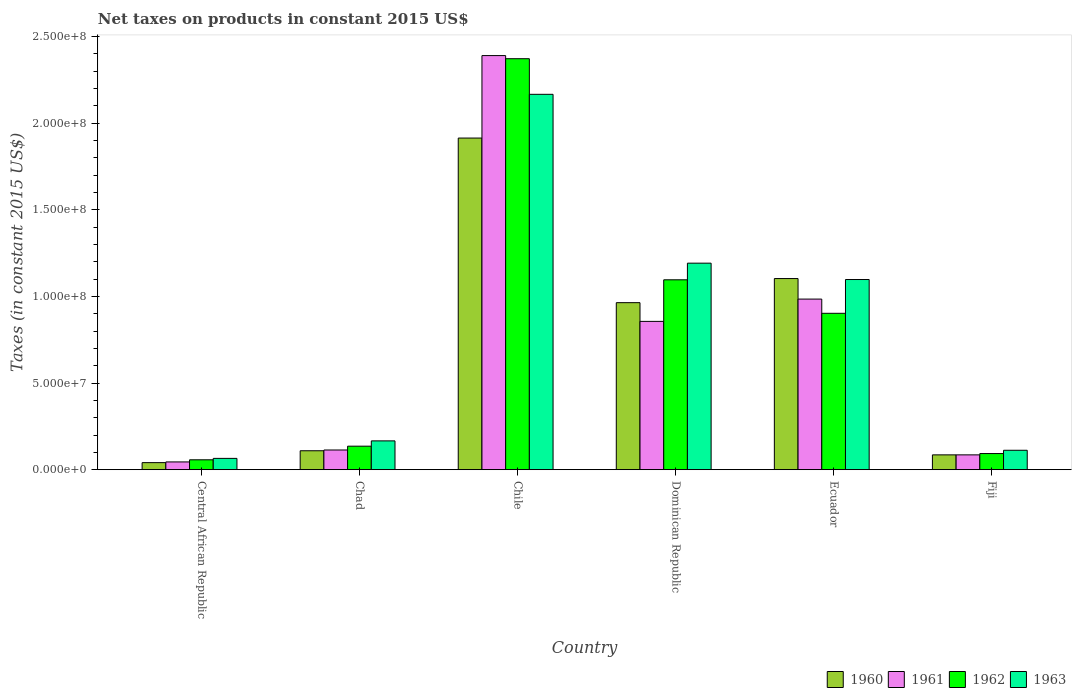How many different coloured bars are there?
Give a very brief answer. 4. How many groups of bars are there?
Offer a terse response. 6. Are the number of bars on each tick of the X-axis equal?
Your answer should be very brief. Yes. How many bars are there on the 2nd tick from the left?
Your answer should be very brief. 4. What is the label of the 4th group of bars from the left?
Offer a terse response. Dominican Republic. What is the net taxes on products in 1962 in Fiji?
Offer a terse response. 9.32e+06. Across all countries, what is the maximum net taxes on products in 1963?
Ensure brevity in your answer.  2.17e+08. Across all countries, what is the minimum net taxes on products in 1963?
Provide a short and direct response. 6.53e+06. In which country was the net taxes on products in 1963 minimum?
Offer a terse response. Central African Republic. What is the total net taxes on products in 1963 in the graph?
Your answer should be very brief. 4.80e+08. What is the difference between the net taxes on products in 1960 in Chile and that in Ecuador?
Make the answer very short. 8.11e+07. What is the difference between the net taxes on products in 1962 in Dominican Republic and the net taxes on products in 1963 in Chile?
Offer a very short reply. -1.07e+08. What is the average net taxes on products in 1962 per country?
Ensure brevity in your answer.  7.76e+07. What is the difference between the net taxes on products of/in 1960 and net taxes on products of/in 1961 in Central African Republic?
Your answer should be compact. -4.07e+05. In how many countries, is the net taxes on products in 1962 greater than 140000000 US$?
Provide a short and direct response. 1. What is the ratio of the net taxes on products in 1963 in Chad to that in Fiji?
Provide a short and direct response. 1.48. Is the net taxes on products in 1963 in Chile less than that in Ecuador?
Your answer should be compact. No. What is the difference between the highest and the second highest net taxes on products in 1962?
Your answer should be compact. 1.93e+07. What is the difference between the highest and the lowest net taxes on products in 1963?
Provide a short and direct response. 2.10e+08. Is the sum of the net taxes on products in 1961 in Dominican Republic and Ecuador greater than the maximum net taxes on products in 1963 across all countries?
Give a very brief answer. No. Is it the case that in every country, the sum of the net taxes on products in 1960 and net taxes on products in 1963 is greater than the sum of net taxes on products in 1962 and net taxes on products in 1961?
Provide a succinct answer. No. What does the 4th bar from the left in Central African Republic represents?
Your answer should be compact. 1963. Is it the case that in every country, the sum of the net taxes on products in 1963 and net taxes on products in 1960 is greater than the net taxes on products in 1961?
Give a very brief answer. Yes. Are all the bars in the graph horizontal?
Your response must be concise. No. How many countries are there in the graph?
Keep it short and to the point. 6. Does the graph contain grids?
Offer a very short reply. No. How many legend labels are there?
Keep it short and to the point. 4. How are the legend labels stacked?
Provide a succinct answer. Horizontal. What is the title of the graph?
Keep it short and to the point. Net taxes on products in constant 2015 US$. Does "1972" appear as one of the legend labels in the graph?
Give a very brief answer. No. What is the label or title of the X-axis?
Make the answer very short. Country. What is the label or title of the Y-axis?
Offer a terse response. Taxes (in constant 2015 US$). What is the Taxes (in constant 2015 US$) of 1960 in Central African Republic?
Offer a very short reply. 4.08e+06. What is the Taxes (in constant 2015 US$) of 1961 in Central African Republic?
Offer a terse response. 4.49e+06. What is the Taxes (in constant 2015 US$) in 1962 in Central African Republic?
Your answer should be compact. 5.71e+06. What is the Taxes (in constant 2015 US$) in 1963 in Central African Republic?
Offer a very short reply. 6.53e+06. What is the Taxes (in constant 2015 US$) of 1960 in Chad?
Ensure brevity in your answer.  1.09e+07. What is the Taxes (in constant 2015 US$) in 1961 in Chad?
Offer a very short reply. 1.14e+07. What is the Taxes (in constant 2015 US$) of 1962 in Chad?
Give a very brief answer. 1.36e+07. What is the Taxes (in constant 2015 US$) in 1963 in Chad?
Make the answer very short. 1.66e+07. What is the Taxes (in constant 2015 US$) in 1960 in Chile?
Your answer should be compact. 1.91e+08. What is the Taxes (in constant 2015 US$) of 1961 in Chile?
Your answer should be very brief. 2.39e+08. What is the Taxes (in constant 2015 US$) in 1962 in Chile?
Your response must be concise. 2.37e+08. What is the Taxes (in constant 2015 US$) in 1963 in Chile?
Offer a terse response. 2.17e+08. What is the Taxes (in constant 2015 US$) in 1960 in Dominican Republic?
Provide a short and direct response. 9.64e+07. What is the Taxes (in constant 2015 US$) in 1961 in Dominican Republic?
Keep it short and to the point. 8.56e+07. What is the Taxes (in constant 2015 US$) in 1962 in Dominican Republic?
Offer a terse response. 1.10e+08. What is the Taxes (in constant 2015 US$) of 1963 in Dominican Republic?
Give a very brief answer. 1.19e+08. What is the Taxes (in constant 2015 US$) of 1960 in Ecuador?
Provide a succinct answer. 1.10e+08. What is the Taxes (in constant 2015 US$) in 1961 in Ecuador?
Make the answer very short. 9.85e+07. What is the Taxes (in constant 2015 US$) of 1962 in Ecuador?
Ensure brevity in your answer.  9.03e+07. What is the Taxes (in constant 2015 US$) of 1963 in Ecuador?
Your answer should be very brief. 1.10e+08. What is the Taxes (in constant 2015 US$) in 1960 in Fiji?
Your answer should be very brief. 8.56e+06. What is the Taxes (in constant 2015 US$) of 1961 in Fiji?
Ensure brevity in your answer.  8.56e+06. What is the Taxes (in constant 2015 US$) of 1962 in Fiji?
Give a very brief answer. 9.32e+06. What is the Taxes (in constant 2015 US$) in 1963 in Fiji?
Give a very brief answer. 1.12e+07. Across all countries, what is the maximum Taxes (in constant 2015 US$) of 1960?
Your answer should be very brief. 1.91e+08. Across all countries, what is the maximum Taxes (in constant 2015 US$) in 1961?
Your answer should be very brief. 2.39e+08. Across all countries, what is the maximum Taxes (in constant 2015 US$) in 1962?
Keep it short and to the point. 2.37e+08. Across all countries, what is the maximum Taxes (in constant 2015 US$) of 1963?
Provide a short and direct response. 2.17e+08. Across all countries, what is the minimum Taxes (in constant 2015 US$) of 1960?
Your answer should be very brief. 4.08e+06. Across all countries, what is the minimum Taxes (in constant 2015 US$) of 1961?
Give a very brief answer. 4.49e+06. Across all countries, what is the minimum Taxes (in constant 2015 US$) in 1962?
Give a very brief answer. 5.71e+06. Across all countries, what is the minimum Taxes (in constant 2015 US$) of 1963?
Offer a terse response. 6.53e+06. What is the total Taxes (in constant 2015 US$) of 1960 in the graph?
Provide a short and direct response. 4.22e+08. What is the total Taxes (in constant 2015 US$) of 1961 in the graph?
Make the answer very short. 4.47e+08. What is the total Taxes (in constant 2015 US$) in 1962 in the graph?
Provide a short and direct response. 4.66e+08. What is the total Taxes (in constant 2015 US$) of 1963 in the graph?
Offer a terse response. 4.80e+08. What is the difference between the Taxes (in constant 2015 US$) in 1960 in Central African Republic and that in Chad?
Offer a very short reply. -6.86e+06. What is the difference between the Taxes (in constant 2015 US$) in 1961 in Central African Republic and that in Chad?
Keep it short and to the point. -6.88e+06. What is the difference between the Taxes (in constant 2015 US$) of 1962 in Central African Republic and that in Chad?
Provide a succinct answer. -7.86e+06. What is the difference between the Taxes (in constant 2015 US$) of 1963 in Central African Republic and that in Chad?
Keep it short and to the point. -1.01e+07. What is the difference between the Taxes (in constant 2015 US$) of 1960 in Central African Republic and that in Chile?
Your answer should be compact. -1.87e+08. What is the difference between the Taxes (in constant 2015 US$) in 1961 in Central African Republic and that in Chile?
Give a very brief answer. -2.35e+08. What is the difference between the Taxes (in constant 2015 US$) of 1962 in Central African Republic and that in Chile?
Your response must be concise. -2.31e+08. What is the difference between the Taxes (in constant 2015 US$) of 1963 in Central African Republic and that in Chile?
Give a very brief answer. -2.10e+08. What is the difference between the Taxes (in constant 2015 US$) in 1960 in Central African Republic and that in Dominican Republic?
Provide a short and direct response. -9.23e+07. What is the difference between the Taxes (in constant 2015 US$) of 1961 in Central African Republic and that in Dominican Republic?
Keep it short and to the point. -8.11e+07. What is the difference between the Taxes (in constant 2015 US$) in 1962 in Central African Republic and that in Dominican Republic?
Make the answer very short. -1.04e+08. What is the difference between the Taxes (in constant 2015 US$) of 1963 in Central African Republic and that in Dominican Republic?
Ensure brevity in your answer.  -1.13e+08. What is the difference between the Taxes (in constant 2015 US$) in 1960 in Central African Republic and that in Ecuador?
Ensure brevity in your answer.  -1.06e+08. What is the difference between the Taxes (in constant 2015 US$) of 1961 in Central African Republic and that in Ecuador?
Your response must be concise. -9.40e+07. What is the difference between the Taxes (in constant 2015 US$) of 1962 in Central African Republic and that in Ecuador?
Keep it short and to the point. -8.45e+07. What is the difference between the Taxes (in constant 2015 US$) of 1963 in Central African Republic and that in Ecuador?
Offer a terse response. -1.03e+08. What is the difference between the Taxes (in constant 2015 US$) in 1960 in Central African Republic and that in Fiji?
Keep it short and to the point. -4.49e+06. What is the difference between the Taxes (in constant 2015 US$) in 1961 in Central African Republic and that in Fiji?
Provide a short and direct response. -4.08e+06. What is the difference between the Taxes (in constant 2015 US$) of 1962 in Central African Republic and that in Fiji?
Provide a succinct answer. -3.61e+06. What is the difference between the Taxes (in constant 2015 US$) of 1963 in Central African Republic and that in Fiji?
Your answer should be compact. -4.68e+06. What is the difference between the Taxes (in constant 2015 US$) of 1960 in Chad and that in Chile?
Make the answer very short. -1.80e+08. What is the difference between the Taxes (in constant 2015 US$) of 1961 in Chad and that in Chile?
Provide a short and direct response. -2.28e+08. What is the difference between the Taxes (in constant 2015 US$) in 1962 in Chad and that in Chile?
Keep it short and to the point. -2.24e+08. What is the difference between the Taxes (in constant 2015 US$) of 1963 in Chad and that in Chile?
Your response must be concise. -2.00e+08. What is the difference between the Taxes (in constant 2015 US$) of 1960 in Chad and that in Dominican Republic?
Provide a succinct answer. -8.55e+07. What is the difference between the Taxes (in constant 2015 US$) of 1961 in Chad and that in Dominican Republic?
Provide a short and direct response. -7.42e+07. What is the difference between the Taxes (in constant 2015 US$) of 1962 in Chad and that in Dominican Republic?
Keep it short and to the point. -9.60e+07. What is the difference between the Taxes (in constant 2015 US$) of 1963 in Chad and that in Dominican Republic?
Provide a short and direct response. -1.03e+08. What is the difference between the Taxes (in constant 2015 US$) of 1960 in Chad and that in Ecuador?
Your response must be concise. -9.94e+07. What is the difference between the Taxes (in constant 2015 US$) of 1961 in Chad and that in Ecuador?
Ensure brevity in your answer.  -8.71e+07. What is the difference between the Taxes (in constant 2015 US$) of 1962 in Chad and that in Ecuador?
Give a very brief answer. -7.67e+07. What is the difference between the Taxes (in constant 2015 US$) in 1963 in Chad and that in Ecuador?
Provide a succinct answer. -9.31e+07. What is the difference between the Taxes (in constant 2015 US$) of 1960 in Chad and that in Fiji?
Your answer should be compact. 2.37e+06. What is the difference between the Taxes (in constant 2015 US$) of 1961 in Chad and that in Fiji?
Your answer should be very brief. 2.81e+06. What is the difference between the Taxes (in constant 2015 US$) in 1962 in Chad and that in Fiji?
Your answer should be compact. 4.25e+06. What is the difference between the Taxes (in constant 2015 US$) in 1963 in Chad and that in Fiji?
Make the answer very short. 5.43e+06. What is the difference between the Taxes (in constant 2015 US$) in 1960 in Chile and that in Dominican Republic?
Provide a succinct answer. 9.50e+07. What is the difference between the Taxes (in constant 2015 US$) in 1961 in Chile and that in Dominican Republic?
Make the answer very short. 1.53e+08. What is the difference between the Taxes (in constant 2015 US$) of 1962 in Chile and that in Dominican Republic?
Offer a very short reply. 1.28e+08. What is the difference between the Taxes (in constant 2015 US$) of 1963 in Chile and that in Dominican Republic?
Your response must be concise. 9.74e+07. What is the difference between the Taxes (in constant 2015 US$) in 1960 in Chile and that in Ecuador?
Give a very brief answer. 8.11e+07. What is the difference between the Taxes (in constant 2015 US$) in 1961 in Chile and that in Ecuador?
Keep it short and to the point. 1.41e+08. What is the difference between the Taxes (in constant 2015 US$) of 1962 in Chile and that in Ecuador?
Ensure brevity in your answer.  1.47e+08. What is the difference between the Taxes (in constant 2015 US$) in 1963 in Chile and that in Ecuador?
Offer a very short reply. 1.07e+08. What is the difference between the Taxes (in constant 2015 US$) in 1960 in Chile and that in Fiji?
Make the answer very short. 1.83e+08. What is the difference between the Taxes (in constant 2015 US$) in 1961 in Chile and that in Fiji?
Provide a succinct answer. 2.30e+08. What is the difference between the Taxes (in constant 2015 US$) of 1962 in Chile and that in Fiji?
Provide a short and direct response. 2.28e+08. What is the difference between the Taxes (in constant 2015 US$) in 1963 in Chile and that in Fiji?
Offer a very short reply. 2.05e+08. What is the difference between the Taxes (in constant 2015 US$) in 1960 in Dominican Republic and that in Ecuador?
Offer a terse response. -1.39e+07. What is the difference between the Taxes (in constant 2015 US$) of 1961 in Dominican Republic and that in Ecuador?
Give a very brief answer. -1.29e+07. What is the difference between the Taxes (in constant 2015 US$) in 1962 in Dominican Republic and that in Ecuador?
Keep it short and to the point. 1.93e+07. What is the difference between the Taxes (in constant 2015 US$) of 1963 in Dominican Republic and that in Ecuador?
Make the answer very short. 9.44e+06. What is the difference between the Taxes (in constant 2015 US$) in 1960 in Dominican Republic and that in Fiji?
Your response must be concise. 8.78e+07. What is the difference between the Taxes (in constant 2015 US$) in 1961 in Dominican Republic and that in Fiji?
Keep it short and to the point. 7.70e+07. What is the difference between the Taxes (in constant 2015 US$) of 1962 in Dominican Republic and that in Fiji?
Your response must be concise. 1.00e+08. What is the difference between the Taxes (in constant 2015 US$) of 1963 in Dominican Republic and that in Fiji?
Make the answer very short. 1.08e+08. What is the difference between the Taxes (in constant 2015 US$) of 1960 in Ecuador and that in Fiji?
Your response must be concise. 1.02e+08. What is the difference between the Taxes (in constant 2015 US$) of 1961 in Ecuador and that in Fiji?
Provide a short and direct response. 8.99e+07. What is the difference between the Taxes (in constant 2015 US$) of 1962 in Ecuador and that in Fiji?
Keep it short and to the point. 8.09e+07. What is the difference between the Taxes (in constant 2015 US$) in 1963 in Ecuador and that in Fiji?
Offer a very short reply. 9.86e+07. What is the difference between the Taxes (in constant 2015 US$) in 1960 in Central African Republic and the Taxes (in constant 2015 US$) in 1961 in Chad?
Offer a very short reply. -7.29e+06. What is the difference between the Taxes (in constant 2015 US$) of 1960 in Central African Republic and the Taxes (in constant 2015 US$) of 1962 in Chad?
Make the answer very short. -9.49e+06. What is the difference between the Taxes (in constant 2015 US$) in 1960 in Central African Republic and the Taxes (in constant 2015 US$) in 1963 in Chad?
Provide a short and direct response. -1.26e+07. What is the difference between the Taxes (in constant 2015 US$) of 1961 in Central African Republic and the Taxes (in constant 2015 US$) of 1962 in Chad?
Your response must be concise. -9.08e+06. What is the difference between the Taxes (in constant 2015 US$) of 1961 in Central African Republic and the Taxes (in constant 2015 US$) of 1963 in Chad?
Provide a short and direct response. -1.21e+07. What is the difference between the Taxes (in constant 2015 US$) of 1962 in Central African Republic and the Taxes (in constant 2015 US$) of 1963 in Chad?
Your response must be concise. -1.09e+07. What is the difference between the Taxes (in constant 2015 US$) in 1960 in Central African Republic and the Taxes (in constant 2015 US$) in 1961 in Chile?
Ensure brevity in your answer.  -2.35e+08. What is the difference between the Taxes (in constant 2015 US$) in 1960 in Central African Republic and the Taxes (in constant 2015 US$) in 1962 in Chile?
Provide a short and direct response. -2.33e+08. What is the difference between the Taxes (in constant 2015 US$) in 1960 in Central African Republic and the Taxes (in constant 2015 US$) in 1963 in Chile?
Ensure brevity in your answer.  -2.13e+08. What is the difference between the Taxes (in constant 2015 US$) of 1961 in Central African Republic and the Taxes (in constant 2015 US$) of 1962 in Chile?
Your answer should be compact. -2.33e+08. What is the difference between the Taxes (in constant 2015 US$) in 1961 in Central African Republic and the Taxes (in constant 2015 US$) in 1963 in Chile?
Offer a very short reply. -2.12e+08. What is the difference between the Taxes (in constant 2015 US$) in 1962 in Central African Republic and the Taxes (in constant 2015 US$) in 1963 in Chile?
Provide a short and direct response. -2.11e+08. What is the difference between the Taxes (in constant 2015 US$) of 1960 in Central African Republic and the Taxes (in constant 2015 US$) of 1961 in Dominican Republic?
Your answer should be compact. -8.15e+07. What is the difference between the Taxes (in constant 2015 US$) of 1960 in Central African Republic and the Taxes (in constant 2015 US$) of 1962 in Dominican Republic?
Provide a succinct answer. -1.06e+08. What is the difference between the Taxes (in constant 2015 US$) of 1960 in Central African Republic and the Taxes (in constant 2015 US$) of 1963 in Dominican Republic?
Provide a succinct answer. -1.15e+08. What is the difference between the Taxes (in constant 2015 US$) in 1961 in Central African Republic and the Taxes (in constant 2015 US$) in 1962 in Dominican Republic?
Make the answer very short. -1.05e+08. What is the difference between the Taxes (in constant 2015 US$) of 1961 in Central African Republic and the Taxes (in constant 2015 US$) of 1963 in Dominican Republic?
Your answer should be very brief. -1.15e+08. What is the difference between the Taxes (in constant 2015 US$) in 1962 in Central African Republic and the Taxes (in constant 2015 US$) in 1963 in Dominican Republic?
Your response must be concise. -1.13e+08. What is the difference between the Taxes (in constant 2015 US$) in 1960 in Central African Republic and the Taxes (in constant 2015 US$) in 1961 in Ecuador?
Your response must be concise. -9.44e+07. What is the difference between the Taxes (in constant 2015 US$) in 1960 in Central African Republic and the Taxes (in constant 2015 US$) in 1962 in Ecuador?
Provide a succinct answer. -8.62e+07. What is the difference between the Taxes (in constant 2015 US$) of 1960 in Central African Republic and the Taxes (in constant 2015 US$) of 1963 in Ecuador?
Your answer should be very brief. -1.06e+08. What is the difference between the Taxes (in constant 2015 US$) in 1961 in Central African Republic and the Taxes (in constant 2015 US$) in 1962 in Ecuador?
Make the answer very short. -8.58e+07. What is the difference between the Taxes (in constant 2015 US$) in 1961 in Central African Republic and the Taxes (in constant 2015 US$) in 1963 in Ecuador?
Give a very brief answer. -1.05e+08. What is the difference between the Taxes (in constant 2015 US$) in 1962 in Central African Republic and the Taxes (in constant 2015 US$) in 1963 in Ecuador?
Provide a succinct answer. -1.04e+08. What is the difference between the Taxes (in constant 2015 US$) in 1960 in Central African Republic and the Taxes (in constant 2015 US$) in 1961 in Fiji?
Offer a terse response. -4.49e+06. What is the difference between the Taxes (in constant 2015 US$) in 1960 in Central African Republic and the Taxes (in constant 2015 US$) in 1962 in Fiji?
Offer a very short reply. -5.24e+06. What is the difference between the Taxes (in constant 2015 US$) of 1960 in Central African Republic and the Taxes (in constant 2015 US$) of 1963 in Fiji?
Your answer should be compact. -7.13e+06. What is the difference between the Taxes (in constant 2015 US$) in 1961 in Central African Republic and the Taxes (in constant 2015 US$) in 1962 in Fiji?
Give a very brief answer. -4.83e+06. What is the difference between the Taxes (in constant 2015 US$) of 1961 in Central African Republic and the Taxes (in constant 2015 US$) of 1963 in Fiji?
Provide a short and direct response. -6.72e+06. What is the difference between the Taxes (in constant 2015 US$) of 1962 in Central African Republic and the Taxes (in constant 2015 US$) of 1963 in Fiji?
Your answer should be compact. -5.49e+06. What is the difference between the Taxes (in constant 2015 US$) of 1960 in Chad and the Taxes (in constant 2015 US$) of 1961 in Chile?
Ensure brevity in your answer.  -2.28e+08. What is the difference between the Taxes (in constant 2015 US$) of 1960 in Chad and the Taxes (in constant 2015 US$) of 1962 in Chile?
Provide a succinct answer. -2.26e+08. What is the difference between the Taxes (in constant 2015 US$) of 1960 in Chad and the Taxes (in constant 2015 US$) of 1963 in Chile?
Offer a terse response. -2.06e+08. What is the difference between the Taxes (in constant 2015 US$) in 1961 in Chad and the Taxes (in constant 2015 US$) in 1962 in Chile?
Your answer should be very brief. -2.26e+08. What is the difference between the Taxes (in constant 2015 US$) in 1961 in Chad and the Taxes (in constant 2015 US$) in 1963 in Chile?
Ensure brevity in your answer.  -2.05e+08. What is the difference between the Taxes (in constant 2015 US$) in 1962 in Chad and the Taxes (in constant 2015 US$) in 1963 in Chile?
Provide a succinct answer. -2.03e+08. What is the difference between the Taxes (in constant 2015 US$) of 1960 in Chad and the Taxes (in constant 2015 US$) of 1961 in Dominican Republic?
Offer a terse response. -7.47e+07. What is the difference between the Taxes (in constant 2015 US$) in 1960 in Chad and the Taxes (in constant 2015 US$) in 1962 in Dominican Republic?
Provide a short and direct response. -9.87e+07. What is the difference between the Taxes (in constant 2015 US$) in 1960 in Chad and the Taxes (in constant 2015 US$) in 1963 in Dominican Republic?
Your answer should be compact. -1.08e+08. What is the difference between the Taxes (in constant 2015 US$) in 1961 in Chad and the Taxes (in constant 2015 US$) in 1962 in Dominican Republic?
Ensure brevity in your answer.  -9.82e+07. What is the difference between the Taxes (in constant 2015 US$) of 1961 in Chad and the Taxes (in constant 2015 US$) of 1963 in Dominican Republic?
Offer a terse response. -1.08e+08. What is the difference between the Taxes (in constant 2015 US$) of 1962 in Chad and the Taxes (in constant 2015 US$) of 1963 in Dominican Republic?
Your answer should be very brief. -1.06e+08. What is the difference between the Taxes (in constant 2015 US$) in 1960 in Chad and the Taxes (in constant 2015 US$) in 1961 in Ecuador?
Offer a very short reply. -8.75e+07. What is the difference between the Taxes (in constant 2015 US$) of 1960 in Chad and the Taxes (in constant 2015 US$) of 1962 in Ecuador?
Give a very brief answer. -7.93e+07. What is the difference between the Taxes (in constant 2015 US$) of 1960 in Chad and the Taxes (in constant 2015 US$) of 1963 in Ecuador?
Keep it short and to the point. -9.88e+07. What is the difference between the Taxes (in constant 2015 US$) of 1961 in Chad and the Taxes (in constant 2015 US$) of 1962 in Ecuador?
Provide a short and direct response. -7.89e+07. What is the difference between the Taxes (in constant 2015 US$) in 1961 in Chad and the Taxes (in constant 2015 US$) in 1963 in Ecuador?
Your answer should be compact. -9.84e+07. What is the difference between the Taxes (in constant 2015 US$) in 1962 in Chad and the Taxes (in constant 2015 US$) in 1963 in Ecuador?
Give a very brief answer. -9.62e+07. What is the difference between the Taxes (in constant 2015 US$) in 1960 in Chad and the Taxes (in constant 2015 US$) in 1961 in Fiji?
Offer a very short reply. 2.37e+06. What is the difference between the Taxes (in constant 2015 US$) of 1960 in Chad and the Taxes (in constant 2015 US$) of 1962 in Fiji?
Provide a short and direct response. 1.62e+06. What is the difference between the Taxes (in constant 2015 US$) in 1960 in Chad and the Taxes (in constant 2015 US$) in 1963 in Fiji?
Make the answer very short. -2.73e+05. What is the difference between the Taxes (in constant 2015 US$) in 1961 in Chad and the Taxes (in constant 2015 US$) in 1962 in Fiji?
Your response must be concise. 2.05e+06. What is the difference between the Taxes (in constant 2015 US$) in 1961 in Chad and the Taxes (in constant 2015 US$) in 1963 in Fiji?
Ensure brevity in your answer.  1.61e+05. What is the difference between the Taxes (in constant 2015 US$) in 1962 in Chad and the Taxes (in constant 2015 US$) in 1963 in Fiji?
Make the answer very short. 2.36e+06. What is the difference between the Taxes (in constant 2015 US$) in 1960 in Chile and the Taxes (in constant 2015 US$) in 1961 in Dominican Republic?
Make the answer very short. 1.06e+08. What is the difference between the Taxes (in constant 2015 US$) of 1960 in Chile and the Taxes (in constant 2015 US$) of 1962 in Dominican Republic?
Offer a very short reply. 8.18e+07. What is the difference between the Taxes (in constant 2015 US$) in 1960 in Chile and the Taxes (in constant 2015 US$) in 1963 in Dominican Republic?
Make the answer very short. 7.22e+07. What is the difference between the Taxes (in constant 2015 US$) of 1961 in Chile and the Taxes (in constant 2015 US$) of 1962 in Dominican Republic?
Offer a terse response. 1.29e+08. What is the difference between the Taxes (in constant 2015 US$) in 1961 in Chile and the Taxes (in constant 2015 US$) in 1963 in Dominican Republic?
Your response must be concise. 1.20e+08. What is the difference between the Taxes (in constant 2015 US$) of 1962 in Chile and the Taxes (in constant 2015 US$) of 1963 in Dominican Republic?
Your answer should be very brief. 1.18e+08. What is the difference between the Taxes (in constant 2015 US$) in 1960 in Chile and the Taxes (in constant 2015 US$) in 1961 in Ecuador?
Provide a short and direct response. 9.29e+07. What is the difference between the Taxes (in constant 2015 US$) of 1960 in Chile and the Taxes (in constant 2015 US$) of 1962 in Ecuador?
Keep it short and to the point. 1.01e+08. What is the difference between the Taxes (in constant 2015 US$) of 1960 in Chile and the Taxes (in constant 2015 US$) of 1963 in Ecuador?
Your response must be concise. 8.16e+07. What is the difference between the Taxes (in constant 2015 US$) in 1961 in Chile and the Taxes (in constant 2015 US$) in 1962 in Ecuador?
Make the answer very short. 1.49e+08. What is the difference between the Taxes (in constant 2015 US$) of 1961 in Chile and the Taxes (in constant 2015 US$) of 1963 in Ecuador?
Your answer should be very brief. 1.29e+08. What is the difference between the Taxes (in constant 2015 US$) in 1962 in Chile and the Taxes (in constant 2015 US$) in 1963 in Ecuador?
Your response must be concise. 1.27e+08. What is the difference between the Taxes (in constant 2015 US$) in 1960 in Chile and the Taxes (in constant 2015 US$) in 1961 in Fiji?
Make the answer very short. 1.83e+08. What is the difference between the Taxes (in constant 2015 US$) in 1960 in Chile and the Taxes (in constant 2015 US$) in 1962 in Fiji?
Provide a short and direct response. 1.82e+08. What is the difference between the Taxes (in constant 2015 US$) of 1960 in Chile and the Taxes (in constant 2015 US$) of 1963 in Fiji?
Offer a very short reply. 1.80e+08. What is the difference between the Taxes (in constant 2015 US$) of 1961 in Chile and the Taxes (in constant 2015 US$) of 1962 in Fiji?
Offer a very short reply. 2.30e+08. What is the difference between the Taxes (in constant 2015 US$) in 1961 in Chile and the Taxes (in constant 2015 US$) in 1963 in Fiji?
Keep it short and to the point. 2.28e+08. What is the difference between the Taxes (in constant 2015 US$) in 1962 in Chile and the Taxes (in constant 2015 US$) in 1963 in Fiji?
Offer a terse response. 2.26e+08. What is the difference between the Taxes (in constant 2015 US$) of 1960 in Dominican Republic and the Taxes (in constant 2015 US$) of 1961 in Ecuador?
Make the answer very short. -2.07e+06. What is the difference between the Taxes (in constant 2015 US$) of 1960 in Dominican Republic and the Taxes (in constant 2015 US$) of 1962 in Ecuador?
Provide a short and direct response. 6.14e+06. What is the difference between the Taxes (in constant 2015 US$) of 1960 in Dominican Republic and the Taxes (in constant 2015 US$) of 1963 in Ecuador?
Make the answer very short. -1.34e+07. What is the difference between the Taxes (in constant 2015 US$) of 1961 in Dominican Republic and the Taxes (in constant 2015 US$) of 1962 in Ecuador?
Give a very brief answer. -4.66e+06. What is the difference between the Taxes (in constant 2015 US$) in 1961 in Dominican Republic and the Taxes (in constant 2015 US$) in 1963 in Ecuador?
Make the answer very short. -2.42e+07. What is the difference between the Taxes (in constant 2015 US$) of 1962 in Dominican Republic and the Taxes (in constant 2015 US$) of 1963 in Ecuador?
Offer a terse response. -1.64e+05. What is the difference between the Taxes (in constant 2015 US$) of 1960 in Dominican Republic and the Taxes (in constant 2015 US$) of 1961 in Fiji?
Make the answer very short. 8.78e+07. What is the difference between the Taxes (in constant 2015 US$) in 1960 in Dominican Republic and the Taxes (in constant 2015 US$) in 1962 in Fiji?
Offer a very short reply. 8.71e+07. What is the difference between the Taxes (in constant 2015 US$) of 1960 in Dominican Republic and the Taxes (in constant 2015 US$) of 1963 in Fiji?
Your answer should be compact. 8.52e+07. What is the difference between the Taxes (in constant 2015 US$) in 1961 in Dominican Republic and the Taxes (in constant 2015 US$) in 1962 in Fiji?
Offer a very short reply. 7.63e+07. What is the difference between the Taxes (in constant 2015 US$) in 1961 in Dominican Republic and the Taxes (in constant 2015 US$) in 1963 in Fiji?
Provide a succinct answer. 7.44e+07. What is the difference between the Taxes (in constant 2015 US$) of 1962 in Dominican Republic and the Taxes (in constant 2015 US$) of 1963 in Fiji?
Your answer should be compact. 9.84e+07. What is the difference between the Taxes (in constant 2015 US$) in 1960 in Ecuador and the Taxes (in constant 2015 US$) in 1961 in Fiji?
Your answer should be compact. 1.02e+08. What is the difference between the Taxes (in constant 2015 US$) in 1960 in Ecuador and the Taxes (in constant 2015 US$) in 1962 in Fiji?
Provide a short and direct response. 1.01e+08. What is the difference between the Taxes (in constant 2015 US$) in 1960 in Ecuador and the Taxes (in constant 2015 US$) in 1963 in Fiji?
Ensure brevity in your answer.  9.91e+07. What is the difference between the Taxes (in constant 2015 US$) in 1961 in Ecuador and the Taxes (in constant 2015 US$) in 1962 in Fiji?
Ensure brevity in your answer.  8.91e+07. What is the difference between the Taxes (in constant 2015 US$) of 1961 in Ecuador and the Taxes (in constant 2015 US$) of 1963 in Fiji?
Keep it short and to the point. 8.73e+07. What is the difference between the Taxes (in constant 2015 US$) of 1962 in Ecuador and the Taxes (in constant 2015 US$) of 1963 in Fiji?
Offer a very short reply. 7.91e+07. What is the average Taxes (in constant 2015 US$) in 1960 per country?
Your response must be concise. 7.03e+07. What is the average Taxes (in constant 2015 US$) in 1961 per country?
Your answer should be very brief. 7.46e+07. What is the average Taxes (in constant 2015 US$) in 1962 per country?
Offer a terse response. 7.76e+07. What is the average Taxes (in constant 2015 US$) of 1963 per country?
Your response must be concise. 8.00e+07. What is the difference between the Taxes (in constant 2015 US$) in 1960 and Taxes (in constant 2015 US$) in 1961 in Central African Republic?
Your answer should be compact. -4.07e+05. What is the difference between the Taxes (in constant 2015 US$) in 1960 and Taxes (in constant 2015 US$) in 1962 in Central African Republic?
Ensure brevity in your answer.  -1.64e+06. What is the difference between the Taxes (in constant 2015 US$) in 1960 and Taxes (in constant 2015 US$) in 1963 in Central African Republic?
Ensure brevity in your answer.  -2.45e+06. What is the difference between the Taxes (in constant 2015 US$) in 1961 and Taxes (in constant 2015 US$) in 1962 in Central African Republic?
Ensure brevity in your answer.  -1.23e+06. What is the difference between the Taxes (in constant 2015 US$) of 1961 and Taxes (in constant 2015 US$) of 1963 in Central African Republic?
Your answer should be compact. -2.05e+06. What is the difference between the Taxes (in constant 2015 US$) in 1962 and Taxes (in constant 2015 US$) in 1963 in Central African Republic?
Make the answer very short. -8.16e+05. What is the difference between the Taxes (in constant 2015 US$) of 1960 and Taxes (in constant 2015 US$) of 1961 in Chad?
Offer a very short reply. -4.34e+05. What is the difference between the Taxes (in constant 2015 US$) of 1960 and Taxes (in constant 2015 US$) of 1962 in Chad?
Keep it short and to the point. -2.63e+06. What is the difference between the Taxes (in constant 2015 US$) in 1960 and Taxes (in constant 2015 US$) in 1963 in Chad?
Your answer should be compact. -5.70e+06. What is the difference between the Taxes (in constant 2015 US$) in 1961 and Taxes (in constant 2015 US$) in 1962 in Chad?
Provide a short and direct response. -2.20e+06. What is the difference between the Taxes (in constant 2015 US$) in 1961 and Taxes (in constant 2015 US$) in 1963 in Chad?
Your answer should be very brief. -5.26e+06. What is the difference between the Taxes (in constant 2015 US$) in 1962 and Taxes (in constant 2015 US$) in 1963 in Chad?
Ensure brevity in your answer.  -3.06e+06. What is the difference between the Taxes (in constant 2015 US$) in 1960 and Taxes (in constant 2015 US$) in 1961 in Chile?
Your response must be concise. -4.76e+07. What is the difference between the Taxes (in constant 2015 US$) in 1960 and Taxes (in constant 2015 US$) in 1962 in Chile?
Your answer should be compact. -4.58e+07. What is the difference between the Taxes (in constant 2015 US$) of 1960 and Taxes (in constant 2015 US$) of 1963 in Chile?
Make the answer very short. -2.52e+07. What is the difference between the Taxes (in constant 2015 US$) in 1961 and Taxes (in constant 2015 US$) in 1962 in Chile?
Provide a succinct answer. 1.81e+06. What is the difference between the Taxes (in constant 2015 US$) of 1961 and Taxes (in constant 2015 US$) of 1963 in Chile?
Provide a short and direct response. 2.24e+07. What is the difference between the Taxes (in constant 2015 US$) of 1962 and Taxes (in constant 2015 US$) of 1963 in Chile?
Your response must be concise. 2.06e+07. What is the difference between the Taxes (in constant 2015 US$) of 1960 and Taxes (in constant 2015 US$) of 1961 in Dominican Republic?
Your response must be concise. 1.08e+07. What is the difference between the Taxes (in constant 2015 US$) in 1960 and Taxes (in constant 2015 US$) in 1962 in Dominican Republic?
Provide a short and direct response. -1.32e+07. What is the difference between the Taxes (in constant 2015 US$) of 1960 and Taxes (in constant 2015 US$) of 1963 in Dominican Republic?
Provide a short and direct response. -2.28e+07. What is the difference between the Taxes (in constant 2015 US$) in 1961 and Taxes (in constant 2015 US$) in 1962 in Dominican Republic?
Your answer should be compact. -2.40e+07. What is the difference between the Taxes (in constant 2015 US$) of 1961 and Taxes (in constant 2015 US$) of 1963 in Dominican Republic?
Offer a terse response. -3.36e+07. What is the difference between the Taxes (in constant 2015 US$) in 1962 and Taxes (in constant 2015 US$) in 1963 in Dominican Republic?
Provide a succinct answer. -9.60e+06. What is the difference between the Taxes (in constant 2015 US$) of 1960 and Taxes (in constant 2015 US$) of 1961 in Ecuador?
Make the answer very short. 1.19e+07. What is the difference between the Taxes (in constant 2015 US$) of 1960 and Taxes (in constant 2015 US$) of 1962 in Ecuador?
Provide a short and direct response. 2.01e+07. What is the difference between the Taxes (in constant 2015 US$) of 1960 and Taxes (in constant 2015 US$) of 1963 in Ecuador?
Keep it short and to the point. 5.57e+05. What is the difference between the Taxes (in constant 2015 US$) in 1961 and Taxes (in constant 2015 US$) in 1962 in Ecuador?
Your answer should be compact. 8.21e+06. What is the difference between the Taxes (in constant 2015 US$) in 1961 and Taxes (in constant 2015 US$) in 1963 in Ecuador?
Your answer should be compact. -1.13e+07. What is the difference between the Taxes (in constant 2015 US$) of 1962 and Taxes (in constant 2015 US$) of 1963 in Ecuador?
Make the answer very short. -1.95e+07. What is the difference between the Taxes (in constant 2015 US$) of 1960 and Taxes (in constant 2015 US$) of 1962 in Fiji?
Provide a short and direct response. -7.56e+05. What is the difference between the Taxes (in constant 2015 US$) in 1960 and Taxes (in constant 2015 US$) in 1963 in Fiji?
Offer a terse response. -2.64e+06. What is the difference between the Taxes (in constant 2015 US$) of 1961 and Taxes (in constant 2015 US$) of 1962 in Fiji?
Provide a succinct answer. -7.56e+05. What is the difference between the Taxes (in constant 2015 US$) of 1961 and Taxes (in constant 2015 US$) of 1963 in Fiji?
Your answer should be very brief. -2.64e+06. What is the difference between the Taxes (in constant 2015 US$) of 1962 and Taxes (in constant 2015 US$) of 1963 in Fiji?
Keep it short and to the point. -1.89e+06. What is the ratio of the Taxes (in constant 2015 US$) of 1960 in Central African Republic to that in Chad?
Your answer should be compact. 0.37. What is the ratio of the Taxes (in constant 2015 US$) in 1961 in Central African Republic to that in Chad?
Your answer should be compact. 0.39. What is the ratio of the Taxes (in constant 2015 US$) of 1962 in Central African Republic to that in Chad?
Provide a short and direct response. 0.42. What is the ratio of the Taxes (in constant 2015 US$) of 1963 in Central African Republic to that in Chad?
Give a very brief answer. 0.39. What is the ratio of the Taxes (in constant 2015 US$) of 1960 in Central African Republic to that in Chile?
Keep it short and to the point. 0.02. What is the ratio of the Taxes (in constant 2015 US$) of 1961 in Central African Republic to that in Chile?
Keep it short and to the point. 0.02. What is the ratio of the Taxes (in constant 2015 US$) in 1962 in Central African Republic to that in Chile?
Your answer should be compact. 0.02. What is the ratio of the Taxes (in constant 2015 US$) in 1963 in Central African Republic to that in Chile?
Your answer should be compact. 0.03. What is the ratio of the Taxes (in constant 2015 US$) of 1960 in Central African Republic to that in Dominican Republic?
Give a very brief answer. 0.04. What is the ratio of the Taxes (in constant 2015 US$) of 1961 in Central African Republic to that in Dominican Republic?
Your answer should be very brief. 0.05. What is the ratio of the Taxes (in constant 2015 US$) in 1962 in Central African Republic to that in Dominican Republic?
Provide a short and direct response. 0.05. What is the ratio of the Taxes (in constant 2015 US$) of 1963 in Central African Republic to that in Dominican Republic?
Keep it short and to the point. 0.05. What is the ratio of the Taxes (in constant 2015 US$) in 1960 in Central African Republic to that in Ecuador?
Provide a succinct answer. 0.04. What is the ratio of the Taxes (in constant 2015 US$) in 1961 in Central African Republic to that in Ecuador?
Your answer should be compact. 0.05. What is the ratio of the Taxes (in constant 2015 US$) of 1962 in Central African Republic to that in Ecuador?
Offer a very short reply. 0.06. What is the ratio of the Taxes (in constant 2015 US$) of 1963 in Central African Republic to that in Ecuador?
Keep it short and to the point. 0.06. What is the ratio of the Taxes (in constant 2015 US$) of 1960 in Central African Republic to that in Fiji?
Your response must be concise. 0.48. What is the ratio of the Taxes (in constant 2015 US$) of 1961 in Central African Republic to that in Fiji?
Your response must be concise. 0.52. What is the ratio of the Taxes (in constant 2015 US$) of 1962 in Central African Republic to that in Fiji?
Your answer should be very brief. 0.61. What is the ratio of the Taxes (in constant 2015 US$) of 1963 in Central African Republic to that in Fiji?
Your answer should be compact. 0.58. What is the ratio of the Taxes (in constant 2015 US$) of 1960 in Chad to that in Chile?
Provide a short and direct response. 0.06. What is the ratio of the Taxes (in constant 2015 US$) in 1961 in Chad to that in Chile?
Provide a succinct answer. 0.05. What is the ratio of the Taxes (in constant 2015 US$) in 1962 in Chad to that in Chile?
Offer a terse response. 0.06. What is the ratio of the Taxes (in constant 2015 US$) of 1963 in Chad to that in Chile?
Your answer should be compact. 0.08. What is the ratio of the Taxes (in constant 2015 US$) of 1960 in Chad to that in Dominican Republic?
Your answer should be compact. 0.11. What is the ratio of the Taxes (in constant 2015 US$) in 1961 in Chad to that in Dominican Republic?
Provide a short and direct response. 0.13. What is the ratio of the Taxes (in constant 2015 US$) of 1962 in Chad to that in Dominican Republic?
Your answer should be compact. 0.12. What is the ratio of the Taxes (in constant 2015 US$) of 1963 in Chad to that in Dominican Republic?
Make the answer very short. 0.14. What is the ratio of the Taxes (in constant 2015 US$) of 1960 in Chad to that in Ecuador?
Offer a terse response. 0.1. What is the ratio of the Taxes (in constant 2015 US$) of 1961 in Chad to that in Ecuador?
Your answer should be compact. 0.12. What is the ratio of the Taxes (in constant 2015 US$) in 1962 in Chad to that in Ecuador?
Provide a short and direct response. 0.15. What is the ratio of the Taxes (in constant 2015 US$) in 1963 in Chad to that in Ecuador?
Ensure brevity in your answer.  0.15. What is the ratio of the Taxes (in constant 2015 US$) of 1960 in Chad to that in Fiji?
Your answer should be very brief. 1.28. What is the ratio of the Taxes (in constant 2015 US$) of 1961 in Chad to that in Fiji?
Offer a terse response. 1.33. What is the ratio of the Taxes (in constant 2015 US$) of 1962 in Chad to that in Fiji?
Your answer should be compact. 1.46. What is the ratio of the Taxes (in constant 2015 US$) in 1963 in Chad to that in Fiji?
Your answer should be compact. 1.48. What is the ratio of the Taxes (in constant 2015 US$) in 1960 in Chile to that in Dominican Republic?
Your answer should be very brief. 1.99. What is the ratio of the Taxes (in constant 2015 US$) of 1961 in Chile to that in Dominican Republic?
Make the answer very short. 2.79. What is the ratio of the Taxes (in constant 2015 US$) of 1962 in Chile to that in Dominican Republic?
Your response must be concise. 2.16. What is the ratio of the Taxes (in constant 2015 US$) in 1963 in Chile to that in Dominican Republic?
Offer a terse response. 1.82. What is the ratio of the Taxes (in constant 2015 US$) in 1960 in Chile to that in Ecuador?
Offer a terse response. 1.74. What is the ratio of the Taxes (in constant 2015 US$) in 1961 in Chile to that in Ecuador?
Keep it short and to the point. 2.43. What is the ratio of the Taxes (in constant 2015 US$) in 1962 in Chile to that in Ecuador?
Provide a succinct answer. 2.63. What is the ratio of the Taxes (in constant 2015 US$) in 1963 in Chile to that in Ecuador?
Ensure brevity in your answer.  1.97. What is the ratio of the Taxes (in constant 2015 US$) in 1960 in Chile to that in Fiji?
Keep it short and to the point. 22.35. What is the ratio of the Taxes (in constant 2015 US$) of 1961 in Chile to that in Fiji?
Your answer should be very brief. 27.91. What is the ratio of the Taxes (in constant 2015 US$) in 1962 in Chile to that in Fiji?
Ensure brevity in your answer.  25.45. What is the ratio of the Taxes (in constant 2015 US$) in 1963 in Chile to that in Fiji?
Your answer should be very brief. 19.33. What is the ratio of the Taxes (in constant 2015 US$) in 1960 in Dominican Republic to that in Ecuador?
Give a very brief answer. 0.87. What is the ratio of the Taxes (in constant 2015 US$) in 1961 in Dominican Republic to that in Ecuador?
Make the answer very short. 0.87. What is the ratio of the Taxes (in constant 2015 US$) of 1962 in Dominican Republic to that in Ecuador?
Offer a terse response. 1.21. What is the ratio of the Taxes (in constant 2015 US$) of 1963 in Dominican Republic to that in Ecuador?
Your response must be concise. 1.09. What is the ratio of the Taxes (in constant 2015 US$) of 1960 in Dominican Republic to that in Fiji?
Your response must be concise. 11.26. What is the ratio of the Taxes (in constant 2015 US$) of 1961 in Dominican Republic to that in Fiji?
Keep it short and to the point. 10. What is the ratio of the Taxes (in constant 2015 US$) of 1962 in Dominican Republic to that in Fiji?
Ensure brevity in your answer.  11.76. What is the ratio of the Taxes (in constant 2015 US$) of 1963 in Dominican Republic to that in Fiji?
Offer a very short reply. 10.63. What is the ratio of the Taxes (in constant 2015 US$) in 1960 in Ecuador to that in Fiji?
Make the answer very short. 12.88. What is the ratio of the Taxes (in constant 2015 US$) of 1961 in Ecuador to that in Fiji?
Your answer should be compact. 11.5. What is the ratio of the Taxes (in constant 2015 US$) in 1962 in Ecuador to that in Fiji?
Give a very brief answer. 9.69. What is the ratio of the Taxes (in constant 2015 US$) of 1963 in Ecuador to that in Fiji?
Provide a succinct answer. 9.79. What is the difference between the highest and the second highest Taxes (in constant 2015 US$) of 1960?
Ensure brevity in your answer.  8.11e+07. What is the difference between the highest and the second highest Taxes (in constant 2015 US$) of 1961?
Make the answer very short. 1.41e+08. What is the difference between the highest and the second highest Taxes (in constant 2015 US$) of 1962?
Keep it short and to the point. 1.28e+08. What is the difference between the highest and the second highest Taxes (in constant 2015 US$) of 1963?
Your answer should be compact. 9.74e+07. What is the difference between the highest and the lowest Taxes (in constant 2015 US$) of 1960?
Provide a short and direct response. 1.87e+08. What is the difference between the highest and the lowest Taxes (in constant 2015 US$) in 1961?
Provide a short and direct response. 2.35e+08. What is the difference between the highest and the lowest Taxes (in constant 2015 US$) in 1962?
Provide a succinct answer. 2.31e+08. What is the difference between the highest and the lowest Taxes (in constant 2015 US$) of 1963?
Your response must be concise. 2.10e+08. 